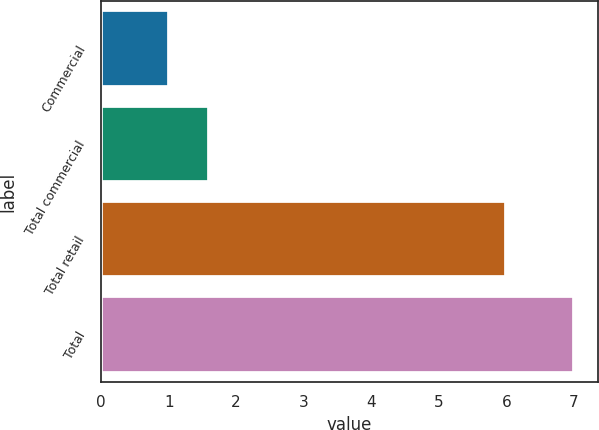Convert chart to OTSL. <chart><loc_0><loc_0><loc_500><loc_500><bar_chart><fcel>Commercial<fcel>Total commercial<fcel>Total retail<fcel>Total<nl><fcel>1<fcel>1.6<fcel>6<fcel>7<nl></chart> 